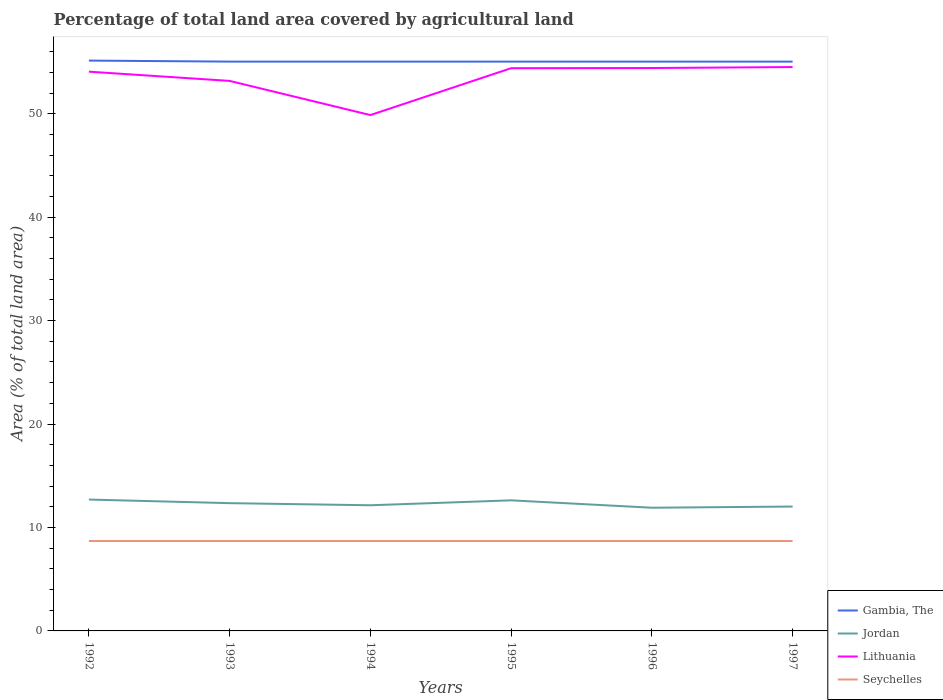How many different coloured lines are there?
Provide a succinct answer. 4. Is the number of lines equal to the number of legend labels?
Make the answer very short. Yes. Across all years, what is the maximum percentage of agricultural land in Lithuania?
Your answer should be very brief. 49.87. What is the total percentage of agricultural land in Seychelles in the graph?
Ensure brevity in your answer.  0. What is the difference between the highest and the second highest percentage of agricultural land in Gambia, The?
Make the answer very short. 0.1. What is the difference between the highest and the lowest percentage of agricultural land in Seychelles?
Provide a short and direct response. 0. Is the percentage of agricultural land in Lithuania strictly greater than the percentage of agricultural land in Seychelles over the years?
Keep it short and to the point. No. How many lines are there?
Your response must be concise. 4. How many years are there in the graph?
Offer a terse response. 6. Are the values on the major ticks of Y-axis written in scientific E-notation?
Your answer should be compact. No. Does the graph contain any zero values?
Your response must be concise. No. How many legend labels are there?
Provide a short and direct response. 4. What is the title of the graph?
Provide a short and direct response. Percentage of total land area covered by agricultural land. What is the label or title of the Y-axis?
Ensure brevity in your answer.  Area (% of total land area). What is the Area (% of total land area) of Gambia, The in 1992?
Make the answer very short. 55.14. What is the Area (% of total land area) in Jordan in 1992?
Provide a short and direct response. 12.7. What is the Area (% of total land area) of Lithuania in 1992?
Provide a succinct answer. 54.07. What is the Area (% of total land area) in Seychelles in 1992?
Provide a succinct answer. 8.7. What is the Area (% of total land area) in Gambia, The in 1993?
Provide a succinct answer. 55.04. What is the Area (% of total land area) in Jordan in 1993?
Provide a short and direct response. 12.35. What is the Area (% of total land area) in Lithuania in 1993?
Offer a very short reply. 53.17. What is the Area (% of total land area) in Seychelles in 1993?
Your response must be concise. 8.7. What is the Area (% of total land area) in Gambia, The in 1994?
Your response must be concise. 55.04. What is the Area (% of total land area) of Jordan in 1994?
Offer a very short reply. 12.15. What is the Area (% of total land area) in Lithuania in 1994?
Your response must be concise. 49.87. What is the Area (% of total land area) in Seychelles in 1994?
Provide a succinct answer. 8.7. What is the Area (% of total land area) of Gambia, The in 1995?
Your answer should be compact. 55.04. What is the Area (% of total land area) in Jordan in 1995?
Keep it short and to the point. 12.62. What is the Area (% of total land area) in Lithuania in 1995?
Your answer should be compact. 54.4. What is the Area (% of total land area) in Seychelles in 1995?
Your answer should be very brief. 8.7. What is the Area (% of total land area) of Gambia, The in 1996?
Make the answer very short. 55.04. What is the Area (% of total land area) of Jordan in 1996?
Your response must be concise. 11.91. What is the Area (% of total land area) in Lithuania in 1996?
Your response must be concise. 54.42. What is the Area (% of total land area) of Seychelles in 1996?
Keep it short and to the point. 8.7. What is the Area (% of total land area) of Gambia, The in 1997?
Your answer should be very brief. 55.04. What is the Area (% of total land area) in Jordan in 1997?
Keep it short and to the point. 12.02. What is the Area (% of total land area) of Lithuania in 1997?
Offer a very short reply. 54.51. What is the Area (% of total land area) in Seychelles in 1997?
Your answer should be very brief. 8.7. Across all years, what is the maximum Area (% of total land area) in Gambia, The?
Your answer should be very brief. 55.14. Across all years, what is the maximum Area (% of total land area) of Jordan?
Your answer should be compact. 12.7. Across all years, what is the maximum Area (% of total land area) in Lithuania?
Your answer should be compact. 54.51. Across all years, what is the maximum Area (% of total land area) in Seychelles?
Offer a very short reply. 8.7. Across all years, what is the minimum Area (% of total land area) of Gambia, The?
Make the answer very short. 55.04. Across all years, what is the minimum Area (% of total land area) in Jordan?
Offer a terse response. 11.91. Across all years, what is the minimum Area (% of total land area) in Lithuania?
Your answer should be very brief. 49.87. Across all years, what is the minimum Area (% of total land area) in Seychelles?
Ensure brevity in your answer.  8.7. What is the total Area (% of total land area) in Gambia, The in the graph?
Your answer should be compact. 330.34. What is the total Area (% of total land area) of Jordan in the graph?
Give a very brief answer. 73.76. What is the total Area (% of total land area) of Lithuania in the graph?
Offer a very short reply. 320.45. What is the total Area (% of total land area) in Seychelles in the graph?
Ensure brevity in your answer.  52.17. What is the difference between the Area (% of total land area) in Gambia, The in 1992 and that in 1993?
Keep it short and to the point. 0.1. What is the difference between the Area (% of total land area) in Jordan in 1992 and that in 1993?
Give a very brief answer. 0.35. What is the difference between the Area (% of total land area) of Lithuania in 1992 and that in 1993?
Make the answer very short. 0.89. What is the difference between the Area (% of total land area) of Gambia, The in 1992 and that in 1994?
Ensure brevity in your answer.  0.1. What is the difference between the Area (% of total land area) in Jordan in 1992 and that in 1994?
Your answer should be very brief. 0.55. What is the difference between the Area (% of total land area) of Lithuania in 1992 and that in 1994?
Keep it short and to the point. 4.2. What is the difference between the Area (% of total land area) in Gambia, The in 1992 and that in 1995?
Make the answer very short. 0.1. What is the difference between the Area (% of total land area) in Jordan in 1992 and that in 1995?
Keep it short and to the point. 0.08. What is the difference between the Area (% of total land area) in Lithuania in 1992 and that in 1995?
Ensure brevity in your answer.  -0.34. What is the difference between the Area (% of total land area) of Seychelles in 1992 and that in 1995?
Ensure brevity in your answer.  0. What is the difference between the Area (% of total land area) in Gambia, The in 1992 and that in 1996?
Your answer should be compact. 0.1. What is the difference between the Area (% of total land area) in Jordan in 1992 and that in 1996?
Give a very brief answer. 0.79. What is the difference between the Area (% of total land area) in Lithuania in 1992 and that in 1996?
Your answer should be very brief. -0.35. What is the difference between the Area (% of total land area) of Gambia, The in 1992 and that in 1997?
Keep it short and to the point. 0.1. What is the difference between the Area (% of total land area) of Jordan in 1992 and that in 1997?
Offer a terse response. 0.68. What is the difference between the Area (% of total land area) in Lithuania in 1992 and that in 1997?
Give a very brief answer. -0.45. What is the difference between the Area (% of total land area) in Seychelles in 1992 and that in 1997?
Offer a very short reply. 0. What is the difference between the Area (% of total land area) of Jordan in 1993 and that in 1994?
Your answer should be compact. 0.2. What is the difference between the Area (% of total land area) in Lithuania in 1993 and that in 1994?
Offer a very short reply. 3.3. What is the difference between the Area (% of total land area) in Seychelles in 1993 and that in 1994?
Provide a short and direct response. 0. What is the difference between the Area (% of total land area) in Jordan in 1993 and that in 1995?
Offer a terse response. -0.27. What is the difference between the Area (% of total land area) in Lithuania in 1993 and that in 1995?
Provide a succinct answer. -1.23. What is the difference between the Area (% of total land area) in Jordan in 1993 and that in 1996?
Provide a succinct answer. 0.44. What is the difference between the Area (% of total land area) in Lithuania in 1993 and that in 1996?
Offer a very short reply. -1.24. What is the difference between the Area (% of total land area) in Seychelles in 1993 and that in 1996?
Make the answer very short. 0. What is the difference between the Area (% of total land area) of Gambia, The in 1993 and that in 1997?
Provide a short and direct response. 0. What is the difference between the Area (% of total land area) of Jordan in 1993 and that in 1997?
Offer a very short reply. 0.33. What is the difference between the Area (% of total land area) in Lithuania in 1993 and that in 1997?
Your answer should be compact. -1.34. What is the difference between the Area (% of total land area) in Seychelles in 1993 and that in 1997?
Make the answer very short. 0. What is the difference between the Area (% of total land area) of Gambia, The in 1994 and that in 1995?
Give a very brief answer. 0. What is the difference between the Area (% of total land area) of Jordan in 1994 and that in 1995?
Offer a very short reply. -0.48. What is the difference between the Area (% of total land area) of Lithuania in 1994 and that in 1995?
Offer a very short reply. -4.53. What is the difference between the Area (% of total land area) in Seychelles in 1994 and that in 1995?
Your answer should be compact. 0. What is the difference between the Area (% of total land area) of Gambia, The in 1994 and that in 1996?
Provide a short and direct response. 0. What is the difference between the Area (% of total land area) of Jordan in 1994 and that in 1996?
Make the answer very short. 0.24. What is the difference between the Area (% of total land area) in Lithuania in 1994 and that in 1996?
Your answer should be very brief. -4.55. What is the difference between the Area (% of total land area) in Jordan in 1994 and that in 1997?
Provide a short and direct response. 0.12. What is the difference between the Area (% of total land area) in Lithuania in 1994 and that in 1997?
Ensure brevity in your answer.  -4.64. What is the difference between the Area (% of total land area) of Seychelles in 1994 and that in 1997?
Give a very brief answer. 0. What is the difference between the Area (% of total land area) of Gambia, The in 1995 and that in 1996?
Provide a short and direct response. 0. What is the difference between the Area (% of total land area) in Jordan in 1995 and that in 1996?
Provide a short and direct response. 0.71. What is the difference between the Area (% of total land area) of Lithuania in 1995 and that in 1996?
Your answer should be compact. -0.02. What is the difference between the Area (% of total land area) of Gambia, The in 1995 and that in 1997?
Make the answer very short. 0. What is the difference between the Area (% of total land area) in Jordan in 1995 and that in 1997?
Provide a succinct answer. 0.6. What is the difference between the Area (% of total land area) of Lithuania in 1995 and that in 1997?
Offer a very short reply. -0.11. What is the difference between the Area (% of total land area) of Seychelles in 1995 and that in 1997?
Offer a terse response. 0. What is the difference between the Area (% of total land area) in Jordan in 1996 and that in 1997?
Offer a very short reply. -0.11. What is the difference between the Area (% of total land area) in Lithuania in 1996 and that in 1997?
Give a very brief answer. -0.1. What is the difference between the Area (% of total land area) of Gambia, The in 1992 and the Area (% of total land area) of Jordan in 1993?
Offer a very short reply. 42.79. What is the difference between the Area (% of total land area) of Gambia, The in 1992 and the Area (% of total land area) of Lithuania in 1993?
Your answer should be very brief. 1.96. What is the difference between the Area (% of total land area) of Gambia, The in 1992 and the Area (% of total land area) of Seychelles in 1993?
Ensure brevity in your answer.  46.44. What is the difference between the Area (% of total land area) of Jordan in 1992 and the Area (% of total land area) of Lithuania in 1993?
Offer a terse response. -40.47. What is the difference between the Area (% of total land area) in Jordan in 1992 and the Area (% of total land area) in Seychelles in 1993?
Offer a terse response. 4. What is the difference between the Area (% of total land area) of Lithuania in 1992 and the Area (% of total land area) of Seychelles in 1993?
Your answer should be very brief. 45.37. What is the difference between the Area (% of total land area) of Gambia, The in 1992 and the Area (% of total land area) of Jordan in 1994?
Keep it short and to the point. 42.99. What is the difference between the Area (% of total land area) of Gambia, The in 1992 and the Area (% of total land area) of Lithuania in 1994?
Provide a succinct answer. 5.27. What is the difference between the Area (% of total land area) of Gambia, The in 1992 and the Area (% of total land area) of Seychelles in 1994?
Your response must be concise. 46.44. What is the difference between the Area (% of total land area) in Jordan in 1992 and the Area (% of total land area) in Lithuania in 1994?
Your answer should be compact. -37.17. What is the difference between the Area (% of total land area) in Jordan in 1992 and the Area (% of total land area) in Seychelles in 1994?
Ensure brevity in your answer.  4. What is the difference between the Area (% of total land area) in Lithuania in 1992 and the Area (% of total land area) in Seychelles in 1994?
Offer a terse response. 45.37. What is the difference between the Area (% of total land area) of Gambia, The in 1992 and the Area (% of total land area) of Jordan in 1995?
Your answer should be very brief. 42.51. What is the difference between the Area (% of total land area) of Gambia, The in 1992 and the Area (% of total land area) of Lithuania in 1995?
Make the answer very short. 0.73. What is the difference between the Area (% of total land area) of Gambia, The in 1992 and the Area (% of total land area) of Seychelles in 1995?
Give a very brief answer. 46.44. What is the difference between the Area (% of total land area) in Jordan in 1992 and the Area (% of total land area) in Lithuania in 1995?
Provide a short and direct response. -41.7. What is the difference between the Area (% of total land area) in Jordan in 1992 and the Area (% of total land area) in Seychelles in 1995?
Your answer should be compact. 4. What is the difference between the Area (% of total land area) of Lithuania in 1992 and the Area (% of total land area) of Seychelles in 1995?
Offer a terse response. 45.37. What is the difference between the Area (% of total land area) in Gambia, The in 1992 and the Area (% of total land area) in Jordan in 1996?
Provide a succinct answer. 43.23. What is the difference between the Area (% of total land area) in Gambia, The in 1992 and the Area (% of total land area) in Lithuania in 1996?
Offer a terse response. 0.72. What is the difference between the Area (% of total land area) of Gambia, The in 1992 and the Area (% of total land area) of Seychelles in 1996?
Offer a terse response. 46.44. What is the difference between the Area (% of total land area) in Jordan in 1992 and the Area (% of total land area) in Lithuania in 1996?
Provide a short and direct response. -41.72. What is the difference between the Area (% of total land area) in Jordan in 1992 and the Area (% of total land area) in Seychelles in 1996?
Offer a very short reply. 4. What is the difference between the Area (% of total land area) in Lithuania in 1992 and the Area (% of total land area) in Seychelles in 1996?
Keep it short and to the point. 45.37. What is the difference between the Area (% of total land area) of Gambia, The in 1992 and the Area (% of total land area) of Jordan in 1997?
Give a very brief answer. 43.11. What is the difference between the Area (% of total land area) of Gambia, The in 1992 and the Area (% of total land area) of Lithuania in 1997?
Your response must be concise. 0.62. What is the difference between the Area (% of total land area) in Gambia, The in 1992 and the Area (% of total land area) in Seychelles in 1997?
Your answer should be compact. 46.44. What is the difference between the Area (% of total land area) in Jordan in 1992 and the Area (% of total land area) in Lithuania in 1997?
Offer a terse response. -41.81. What is the difference between the Area (% of total land area) of Jordan in 1992 and the Area (% of total land area) of Seychelles in 1997?
Offer a terse response. 4. What is the difference between the Area (% of total land area) in Lithuania in 1992 and the Area (% of total land area) in Seychelles in 1997?
Provide a short and direct response. 45.37. What is the difference between the Area (% of total land area) in Gambia, The in 1993 and the Area (% of total land area) in Jordan in 1994?
Give a very brief answer. 42.89. What is the difference between the Area (% of total land area) of Gambia, The in 1993 and the Area (% of total land area) of Lithuania in 1994?
Offer a very short reply. 5.17. What is the difference between the Area (% of total land area) in Gambia, The in 1993 and the Area (% of total land area) in Seychelles in 1994?
Give a very brief answer. 46.34. What is the difference between the Area (% of total land area) of Jordan in 1993 and the Area (% of total land area) of Lithuania in 1994?
Make the answer very short. -37.52. What is the difference between the Area (% of total land area) in Jordan in 1993 and the Area (% of total land area) in Seychelles in 1994?
Your response must be concise. 3.66. What is the difference between the Area (% of total land area) of Lithuania in 1993 and the Area (% of total land area) of Seychelles in 1994?
Provide a succinct answer. 44.48. What is the difference between the Area (% of total land area) in Gambia, The in 1993 and the Area (% of total land area) in Jordan in 1995?
Give a very brief answer. 42.41. What is the difference between the Area (% of total land area) of Gambia, The in 1993 and the Area (% of total land area) of Lithuania in 1995?
Your answer should be very brief. 0.64. What is the difference between the Area (% of total land area) in Gambia, The in 1993 and the Area (% of total land area) in Seychelles in 1995?
Offer a terse response. 46.34. What is the difference between the Area (% of total land area) in Jordan in 1993 and the Area (% of total land area) in Lithuania in 1995?
Offer a very short reply. -42.05. What is the difference between the Area (% of total land area) of Jordan in 1993 and the Area (% of total land area) of Seychelles in 1995?
Offer a very short reply. 3.66. What is the difference between the Area (% of total land area) in Lithuania in 1993 and the Area (% of total land area) in Seychelles in 1995?
Your response must be concise. 44.48. What is the difference between the Area (% of total land area) of Gambia, The in 1993 and the Area (% of total land area) of Jordan in 1996?
Ensure brevity in your answer.  43.13. What is the difference between the Area (% of total land area) in Gambia, The in 1993 and the Area (% of total land area) in Lithuania in 1996?
Ensure brevity in your answer.  0.62. What is the difference between the Area (% of total land area) of Gambia, The in 1993 and the Area (% of total land area) of Seychelles in 1996?
Ensure brevity in your answer.  46.34. What is the difference between the Area (% of total land area) of Jordan in 1993 and the Area (% of total land area) of Lithuania in 1996?
Provide a succinct answer. -42.07. What is the difference between the Area (% of total land area) in Jordan in 1993 and the Area (% of total land area) in Seychelles in 1996?
Make the answer very short. 3.66. What is the difference between the Area (% of total land area) in Lithuania in 1993 and the Area (% of total land area) in Seychelles in 1996?
Your response must be concise. 44.48. What is the difference between the Area (% of total land area) in Gambia, The in 1993 and the Area (% of total land area) in Jordan in 1997?
Offer a terse response. 43.02. What is the difference between the Area (% of total land area) of Gambia, The in 1993 and the Area (% of total land area) of Lithuania in 1997?
Your response must be concise. 0.52. What is the difference between the Area (% of total land area) in Gambia, The in 1993 and the Area (% of total land area) in Seychelles in 1997?
Provide a short and direct response. 46.34. What is the difference between the Area (% of total land area) of Jordan in 1993 and the Area (% of total land area) of Lithuania in 1997?
Give a very brief answer. -42.16. What is the difference between the Area (% of total land area) of Jordan in 1993 and the Area (% of total land area) of Seychelles in 1997?
Keep it short and to the point. 3.66. What is the difference between the Area (% of total land area) in Lithuania in 1993 and the Area (% of total land area) in Seychelles in 1997?
Ensure brevity in your answer.  44.48. What is the difference between the Area (% of total land area) in Gambia, The in 1994 and the Area (% of total land area) in Jordan in 1995?
Offer a very short reply. 42.41. What is the difference between the Area (% of total land area) of Gambia, The in 1994 and the Area (% of total land area) of Lithuania in 1995?
Provide a succinct answer. 0.64. What is the difference between the Area (% of total land area) of Gambia, The in 1994 and the Area (% of total land area) of Seychelles in 1995?
Keep it short and to the point. 46.34. What is the difference between the Area (% of total land area) in Jordan in 1994 and the Area (% of total land area) in Lithuania in 1995?
Offer a very short reply. -42.25. What is the difference between the Area (% of total land area) of Jordan in 1994 and the Area (% of total land area) of Seychelles in 1995?
Ensure brevity in your answer.  3.45. What is the difference between the Area (% of total land area) of Lithuania in 1994 and the Area (% of total land area) of Seychelles in 1995?
Your answer should be compact. 41.18. What is the difference between the Area (% of total land area) in Gambia, The in 1994 and the Area (% of total land area) in Jordan in 1996?
Ensure brevity in your answer.  43.13. What is the difference between the Area (% of total land area) of Gambia, The in 1994 and the Area (% of total land area) of Lithuania in 1996?
Provide a short and direct response. 0.62. What is the difference between the Area (% of total land area) of Gambia, The in 1994 and the Area (% of total land area) of Seychelles in 1996?
Your answer should be very brief. 46.34. What is the difference between the Area (% of total land area) of Jordan in 1994 and the Area (% of total land area) of Lithuania in 1996?
Keep it short and to the point. -42.27. What is the difference between the Area (% of total land area) in Jordan in 1994 and the Area (% of total land area) in Seychelles in 1996?
Your response must be concise. 3.45. What is the difference between the Area (% of total land area) in Lithuania in 1994 and the Area (% of total land area) in Seychelles in 1996?
Give a very brief answer. 41.18. What is the difference between the Area (% of total land area) in Gambia, The in 1994 and the Area (% of total land area) in Jordan in 1997?
Ensure brevity in your answer.  43.02. What is the difference between the Area (% of total land area) in Gambia, The in 1994 and the Area (% of total land area) in Lithuania in 1997?
Give a very brief answer. 0.52. What is the difference between the Area (% of total land area) of Gambia, The in 1994 and the Area (% of total land area) of Seychelles in 1997?
Ensure brevity in your answer.  46.34. What is the difference between the Area (% of total land area) of Jordan in 1994 and the Area (% of total land area) of Lithuania in 1997?
Make the answer very short. -42.37. What is the difference between the Area (% of total land area) of Jordan in 1994 and the Area (% of total land area) of Seychelles in 1997?
Offer a very short reply. 3.45. What is the difference between the Area (% of total land area) of Lithuania in 1994 and the Area (% of total land area) of Seychelles in 1997?
Give a very brief answer. 41.18. What is the difference between the Area (% of total land area) in Gambia, The in 1995 and the Area (% of total land area) in Jordan in 1996?
Provide a succinct answer. 43.13. What is the difference between the Area (% of total land area) in Gambia, The in 1995 and the Area (% of total land area) in Lithuania in 1996?
Provide a short and direct response. 0.62. What is the difference between the Area (% of total land area) in Gambia, The in 1995 and the Area (% of total land area) in Seychelles in 1996?
Your answer should be compact. 46.34. What is the difference between the Area (% of total land area) in Jordan in 1995 and the Area (% of total land area) in Lithuania in 1996?
Give a very brief answer. -41.79. What is the difference between the Area (% of total land area) in Jordan in 1995 and the Area (% of total land area) in Seychelles in 1996?
Provide a short and direct response. 3.93. What is the difference between the Area (% of total land area) of Lithuania in 1995 and the Area (% of total land area) of Seychelles in 1996?
Give a very brief answer. 45.71. What is the difference between the Area (% of total land area) in Gambia, The in 1995 and the Area (% of total land area) in Jordan in 1997?
Your answer should be very brief. 43.02. What is the difference between the Area (% of total land area) in Gambia, The in 1995 and the Area (% of total land area) in Lithuania in 1997?
Your answer should be compact. 0.52. What is the difference between the Area (% of total land area) of Gambia, The in 1995 and the Area (% of total land area) of Seychelles in 1997?
Offer a terse response. 46.34. What is the difference between the Area (% of total land area) in Jordan in 1995 and the Area (% of total land area) in Lithuania in 1997?
Provide a succinct answer. -41.89. What is the difference between the Area (% of total land area) of Jordan in 1995 and the Area (% of total land area) of Seychelles in 1997?
Your response must be concise. 3.93. What is the difference between the Area (% of total land area) in Lithuania in 1995 and the Area (% of total land area) in Seychelles in 1997?
Offer a very short reply. 45.71. What is the difference between the Area (% of total land area) in Gambia, The in 1996 and the Area (% of total land area) in Jordan in 1997?
Your answer should be compact. 43.02. What is the difference between the Area (% of total land area) in Gambia, The in 1996 and the Area (% of total land area) in Lithuania in 1997?
Give a very brief answer. 0.52. What is the difference between the Area (% of total land area) of Gambia, The in 1996 and the Area (% of total land area) of Seychelles in 1997?
Ensure brevity in your answer.  46.34. What is the difference between the Area (% of total land area) in Jordan in 1996 and the Area (% of total land area) in Lithuania in 1997?
Ensure brevity in your answer.  -42.6. What is the difference between the Area (% of total land area) in Jordan in 1996 and the Area (% of total land area) in Seychelles in 1997?
Your answer should be compact. 3.21. What is the difference between the Area (% of total land area) of Lithuania in 1996 and the Area (% of total land area) of Seychelles in 1997?
Your answer should be very brief. 45.72. What is the average Area (% of total land area) in Gambia, The per year?
Make the answer very short. 55.06. What is the average Area (% of total land area) of Jordan per year?
Keep it short and to the point. 12.29. What is the average Area (% of total land area) of Lithuania per year?
Offer a very short reply. 53.41. What is the average Area (% of total land area) in Seychelles per year?
Ensure brevity in your answer.  8.7. In the year 1992, what is the difference between the Area (% of total land area) of Gambia, The and Area (% of total land area) of Jordan?
Ensure brevity in your answer.  42.44. In the year 1992, what is the difference between the Area (% of total land area) in Gambia, The and Area (% of total land area) in Lithuania?
Give a very brief answer. 1.07. In the year 1992, what is the difference between the Area (% of total land area) in Gambia, The and Area (% of total land area) in Seychelles?
Your answer should be compact. 46.44. In the year 1992, what is the difference between the Area (% of total land area) in Jordan and Area (% of total land area) in Lithuania?
Your response must be concise. -41.37. In the year 1992, what is the difference between the Area (% of total land area) of Jordan and Area (% of total land area) of Seychelles?
Provide a succinct answer. 4. In the year 1992, what is the difference between the Area (% of total land area) in Lithuania and Area (% of total land area) in Seychelles?
Your response must be concise. 45.37. In the year 1993, what is the difference between the Area (% of total land area) of Gambia, The and Area (% of total land area) of Jordan?
Make the answer very short. 42.69. In the year 1993, what is the difference between the Area (% of total land area) in Gambia, The and Area (% of total land area) in Lithuania?
Offer a terse response. 1.86. In the year 1993, what is the difference between the Area (% of total land area) of Gambia, The and Area (% of total land area) of Seychelles?
Provide a short and direct response. 46.34. In the year 1993, what is the difference between the Area (% of total land area) of Jordan and Area (% of total land area) of Lithuania?
Give a very brief answer. -40.82. In the year 1993, what is the difference between the Area (% of total land area) of Jordan and Area (% of total land area) of Seychelles?
Provide a succinct answer. 3.66. In the year 1993, what is the difference between the Area (% of total land area) in Lithuania and Area (% of total land area) in Seychelles?
Give a very brief answer. 44.48. In the year 1994, what is the difference between the Area (% of total land area) of Gambia, The and Area (% of total land area) of Jordan?
Your answer should be compact. 42.89. In the year 1994, what is the difference between the Area (% of total land area) in Gambia, The and Area (% of total land area) in Lithuania?
Offer a very short reply. 5.17. In the year 1994, what is the difference between the Area (% of total land area) in Gambia, The and Area (% of total land area) in Seychelles?
Keep it short and to the point. 46.34. In the year 1994, what is the difference between the Area (% of total land area) of Jordan and Area (% of total land area) of Lithuania?
Keep it short and to the point. -37.72. In the year 1994, what is the difference between the Area (% of total land area) in Jordan and Area (% of total land area) in Seychelles?
Keep it short and to the point. 3.45. In the year 1994, what is the difference between the Area (% of total land area) of Lithuania and Area (% of total land area) of Seychelles?
Provide a short and direct response. 41.18. In the year 1995, what is the difference between the Area (% of total land area) in Gambia, The and Area (% of total land area) in Jordan?
Keep it short and to the point. 42.41. In the year 1995, what is the difference between the Area (% of total land area) of Gambia, The and Area (% of total land area) of Lithuania?
Provide a short and direct response. 0.64. In the year 1995, what is the difference between the Area (% of total land area) in Gambia, The and Area (% of total land area) in Seychelles?
Keep it short and to the point. 46.34. In the year 1995, what is the difference between the Area (% of total land area) of Jordan and Area (% of total land area) of Lithuania?
Give a very brief answer. -41.78. In the year 1995, what is the difference between the Area (% of total land area) in Jordan and Area (% of total land area) in Seychelles?
Ensure brevity in your answer.  3.93. In the year 1995, what is the difference between the Area (% of total land area) in Lithuania and Area (% of total land area) in Seychelles?
Give a very brief answer. 45.71. In the year 1996, what is the difference between the Area (% of total land area) of Gambia, The and Area (% of total land area) of Jordan?
Your response must be concise. 43.13. In the year 1996, what is the difference between the Area (% of total land area) in Gambia, The and Area (% of total land area) in Lithuania?
Keep it short and to the point. 0.62. In the year 1996, what is the difference between the Area (% of total land area) of Gambia, The and Area (% of total land area) of Seychelles?
Offer a very short reply. 46.34. In the year 1996, what is the difference between the Area (% of total land area) in Jordan and Area (% of total land area) in Lithuania?
Your response must be concise. -42.51. In the year 1996, what is the difference between the Area (% of total land area) in Jordan and Area (% of total land area) in Seychelles?
Your response must be concise. 3.21. In the year 1996, what is the difference between the Area (% of total land area) in Lithuania and Area (% of total land area) in Seychelles?
Make the answer very short. 45.72. In the year 1997, what is the difference between the Area (% of total land area) of Gambia, The and Area (% of total land area) of Jordan?
Ensure brevity in your answer.  43.02. In the year 1997, what is the difference between the Area (% of total land area) of Gambia, The and Area (% of total land area) of Lithuania?
Provide a succinct answer. 0.52. In the year 1997, what is the difference between the Area (% of total land area) of Gambia, The and Area (% of total land area) of Seychelles?
Offer a terse response. 46.34. In the year 1997, what is the difference between the Area (% of total land area) in Jordan and Area (% of total land area) in Lithuania?
Offer a terse response. -42.49. In the year 1997, what is the difference between the Area (% of total land area) in Jordan and Area (% of total land area) in Seychelles?
Your answer should be compact. 3.33. In the year 1997, what is the difference between the Area (% of total land area) in Lithuania and Area (% of total land area) in Seychelles?
Your response must be concise. 45.82. What is the ratio of the Area (% of total land area) in Jordan in 1992 to that in 1993?
Offer a very short reply. 1.03. What is the ratio of the Area (% of total land area) in Lithuania in 1992 to that in 1993?
Provide a short and direct response. 1.02. What is the ratio of the Area (% of total land area) in Jordan in 1992 to that in 1994?
Your response must be concise. 1.05. What is the ratio of the Area (% of total land area) of Lithuania in 1992 to that in 1994?
Offer a very short reply. 1.08. What is the ratio of the Area (% of total land area) of Gambia, The in 1992 to that in 1995?
Your response must be concise. 1. What is the ratio of the Area (% of total land area) of Lithuania in 1992 to that in 1995?
Keep it short and to the point. 0.99. What is the ratio of the Area (% of total land area) in Gambia, The in 1992 to that in 1996?
Provide a short and direct response. 1. What is the ratio of the Area (% of total land area) of Jordan in 1992 to that in 1996?
Offer a very short reply. 1.07. What is the ratio of the Area (% of total land area) in Seychelles in 1992 to that in 1996?
Make the answer very short. 1. What is the ratio of the Area (% of total land area) in Gambia, The in 1992 to that in 1997?
Ensure brevity in your answer.  1. What is the ratio of the Area (% of total land area) of Jordan in 1992 to that in 1997?
Ensure brevity in your answer.  1.06. What is the ratio of the Area (% of total land area) in Lithuania in 1992 to that in 1997?
Provide a short and direct response. 0.99. What is the ratio of the Area (% of total land area) of Gambia, The in 1993 to that in 1994?
Offer a very short reply. 1. What is the ratio of the Area (% of total land area) in Jordan in 1993 to that in 1994?
Offer a very short reply. 1.02. What is the ratio of the Area (% of total land area) in Lithuania in 1993 to that in 1994?
Provide a short and direct response. 1.07. What is the ratio of the Area (% of total land area) in Gambia, The in 1993 to that in 1995?
Ensure brevity in your answer.  1. What is the ratio of the Area (% of total land area) of Jordan in 1993 to that in 1995?
Your response must be concise. 0.98. What is the ratio of the Area (% of total land area) in Lithuania in 1993 to that in 1995?
Give a very brief answer. 0.98. What is the ratio of the Area (% of total land area) of Gambia, The in 1993 to that in 1996?
Your answer should be very brief. 1. What is the ratio of the Area (% of total land area) of Jordan in 1993 to that in 1996?
Offer a very short reply. 1.04. What is the ratio of the Area (% of total land area) of Lithuania in 1993 to that in 1996?
Provide a short and direct response. 0.98. What is the ratio of the Area (% of total land area) of Seychelles in 1993 to that in 1996?
Give a very brief answer. 1. What is the ratio of the Area (% of total land area) of Jordan in 1993 to that in 1997?
Offer a very short reply. 1.03. What is the ratio of the Area (% of total land area) of Lithuania in 1993 to that in 1997?
Offer a very short reply. 0.98. What is the ratio of the Area (% of total land area) of Seychelles in 1993 to that in 1997?
Provide a short and direct response. 1. What is the ratio of the Area (% of total land area) of Gambia, The in 1994 to that in 1995?
Provide a short and direct response. 1. What is the ratio of the Area (% of total land area) in Jordan in 1994 to that in 1995?
Give a very brief answer. 0.96. What is the ratio of the Area (% of total land area) of Lithuania in 1994 to that in 1995?
Your answer should be very brief. 0.92. What is the ratio of the Area (% of total land area) of Seychelles in 1994 to that in 1995?
Your answer should be compact. 1. What is the ratio of the Area (% of total land area) of Gambia, The in 1994 to that in 1996?
Ensure brevity in your answer.  1. What is the ratio of the Area (% of total land area) of Jordan in 1994 to that in 1996?
Ensure brevity in your answer.  1.02. What is the ratio of the Area (% of total land area) in Lithuania in 1994 to that in 1996?
Provide a short and direct response. 0.92. What is the ratio of the Area (% of total land area) in Seychelles in 1994 to that in 1996?
Keep it short and to the point. 1. What is the ratio of the Area (% of total land area) in Jordan in 1994 to that in 1997?
Offer a terse response. 1.01. What is the ratio of the Area (% of total land area) of Lithuania in 1994 to that in 1997?
Provide a short and direct response. 0.91. What is the ratio of the Area (% of total land area) of Jordan in 1995 to that in 1996?
Give a very brief answer. 1.06. What is the ratio of the Area (% of total land area) of Gambia, The in 1995 to that in 1997?
Keep it short and to the point. 1. What is the ratio of the Area (% of total land area) of Jordan in 1996 to that in 1997?
Your answer should be very brief. 0.99. What is the ratio of the Area (% of total land area) of Seychelles in 1996 to that in 1997?
Your answer should be very brief. 1. What is the difference between the highest and the second highest Area (% of total land area) in Gambia, The?
Offer a very short reply. 0.1. What is the difference between the highest and the second highest Area (% of total land area) in Jordan?
Your answer should be compact. 0.08. What is the difference between the highest and the second highest Area (% of total land area) of Lithuania?
Your answer should be compact. 0.1. What is the difference between the highest and the lowest Area (% of total land area) of Gambia, The?
Your response must be concise. 0.1. What is the difference between the highest and the lowest Area (% of total land area) in Jordan?
Offer a very short reply. 0.79. What is the difference between the highest and the lowest Area (% of total land area) of Lithuania?
Make the answer very short. 4.64. 